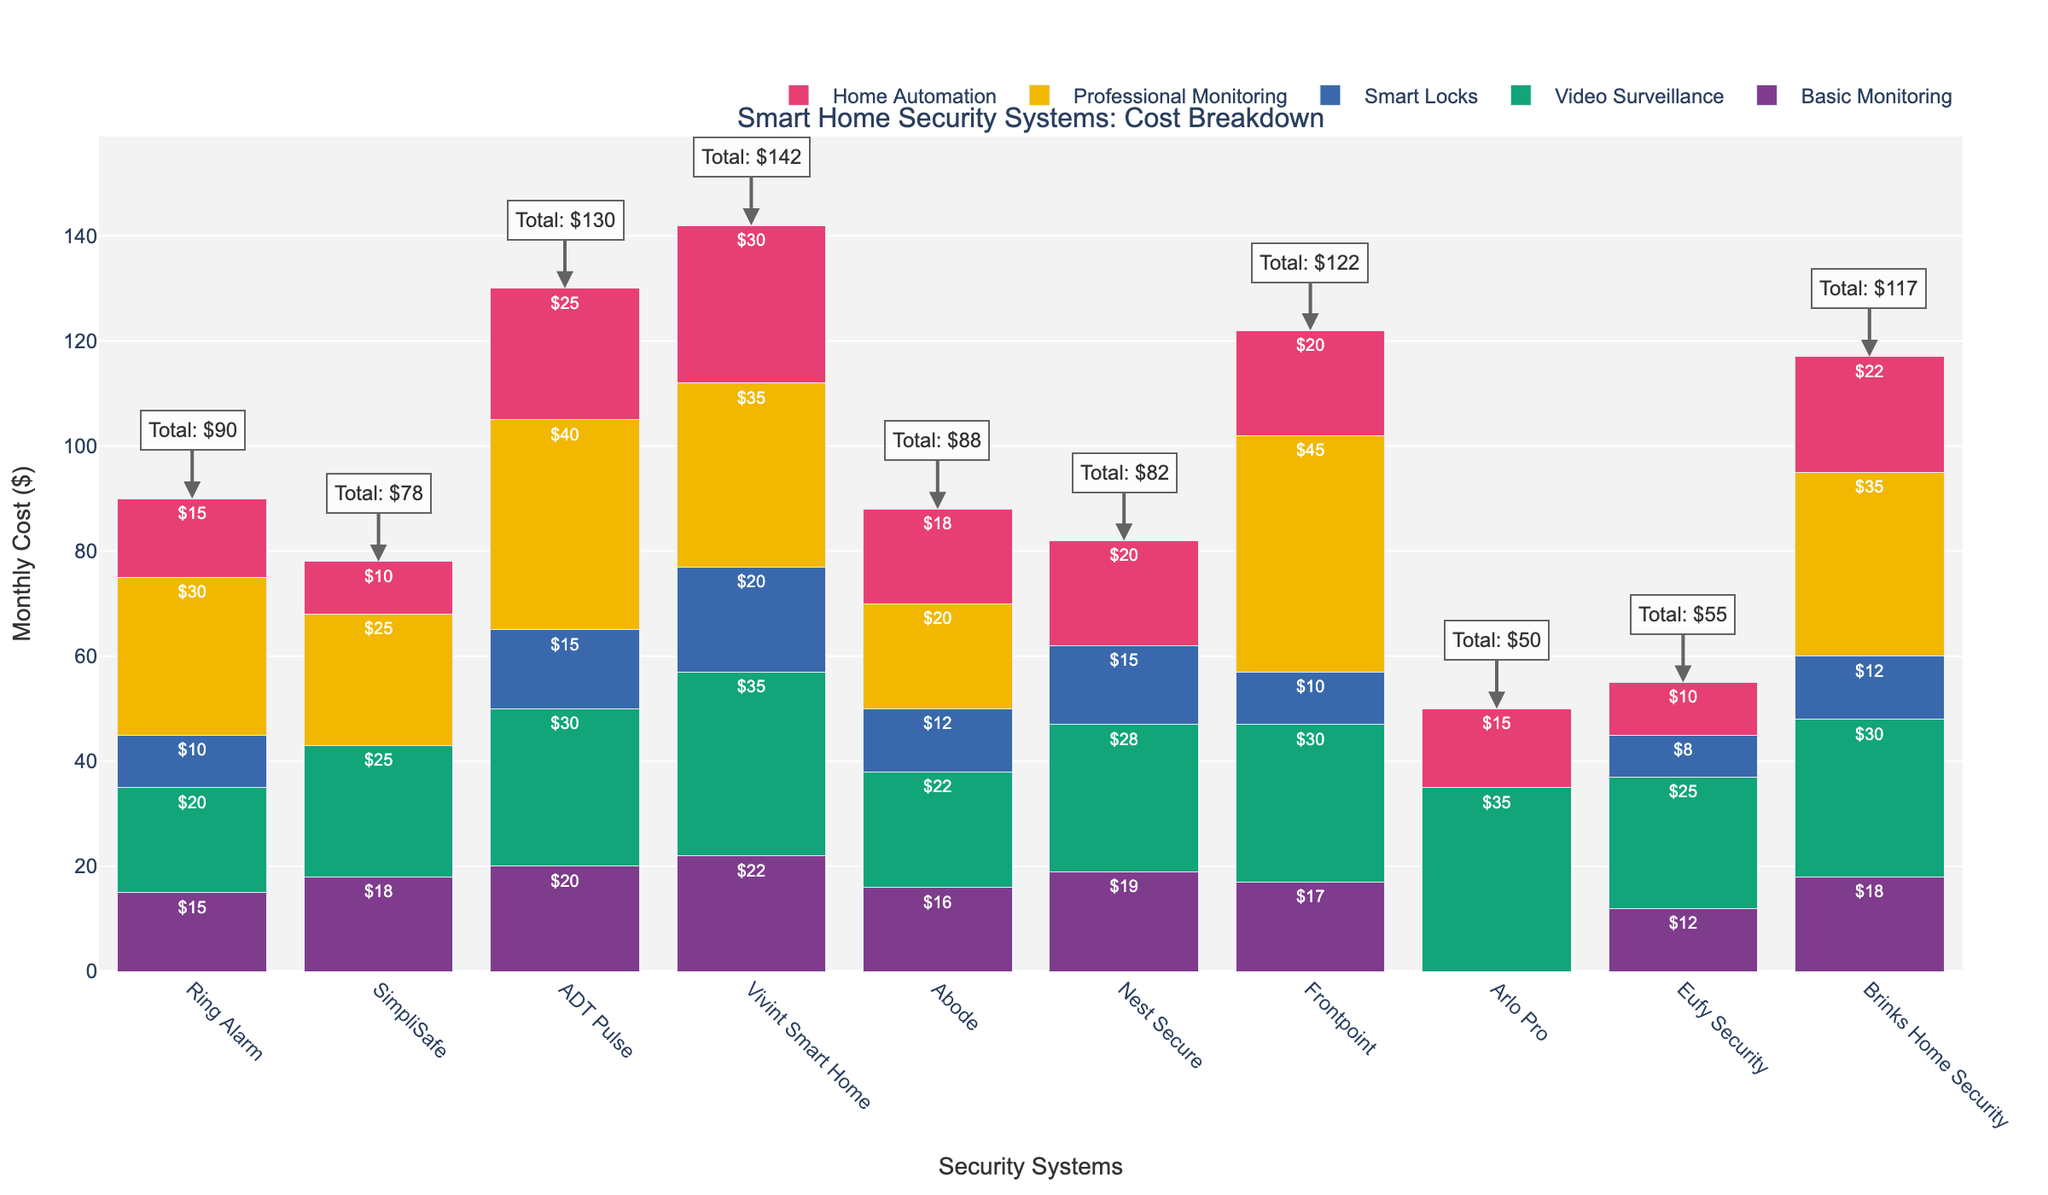What is the most expensive smart home security system in terms of the total monthly cost? Look at the 'Total Cost' annotations for each system. Identify the highest value, which is $142 for Vivint Smart Home.
Answer: Vivint Smart Home Which system charges the most for Professional Monitoring? Compare the heights of the bars representing 'Professional Monitoring' for each system. Identify the tallest bar, which corresponds to Frontpoint at $45.
Answer: Frontpoint What is the cost difference for Home Automation between Vivint Smart Home and ADT Pulse? Subtract the cost of Home Automation for ADT Pulse ($25) from that of Vivint Smart Home ($30). Calculation: $30 - $25.
Answer: $5 How much does SimpliSafe cost more than Eufy Security for Basic Monitoring and Video Surveillance combined? Sum Basic Monitoring and Video Surveillance costs for SimpliSafe ($18 + $25 = $43), and for Eufy Security ($12 + $25 = $37). Then subtract: $43 - $37.
Answer: $6 Which system offers Smart Locks but charges nothing for Professional Monitoring? Identify systems with non-zero 'Smart Locks' bars and zero-height 'Professional Monitoring' bars. Observation: Nest Secure charges $15 for Smart Locks and $0 for Professional Monitoring.
Answer: Nest Secure What is the average cost of Home Automation across all systems that charge for it? Sum the costs of Home Automation for applicable systems: $15 (Ring Alarm) + $10 (SimpliSafe) + $25 (ADT Pulse) + $30 (Vivint Smart Home) + $18 (Abode) + $20 (Nest Secure) + $15 (Arlo Pro) + $10 (Eufy Security) + $22 (Brinks Home Security). Total: 10 systems, $165 in total. Divide by the number of systems: $165/10.
Answer: $16.50 Which system has the lowest total monthly cost and which features does it include? Look at the 'Total Cost' annotations and find the smallest value, which is $50 for Arlo Pro. Compare feature costs for Arlo Pro: only Video Surveillance ($35) and Home Automation ($15).
Answer: Arlo Pro, Video Surveillance and Home Automation Does any system offer Home Automation but not Smart Locks? Check systems with non-zero 'Home Automation' bars and zero-height 'Smart Locks' bars. Eufy Security charges $10 for Home Automation and $0 for Smart Locks.
Answer: Eufy Security How much more does Vivint Smart Home cost in total compared to Abode? Subtract the total cost of Abode ($88) from Vivint Smart Home ($142). Calculation: $142 - $88.
Answer: $54 